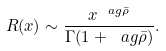<formula> <loc_0><loc_0><loc_500><loc_500>R ( x ) \sim \frac { x ^ { \ a g \bar { \rho } } } { \Gamma ( 1 + \ a g \bar { \rho } ) } .</formula> 